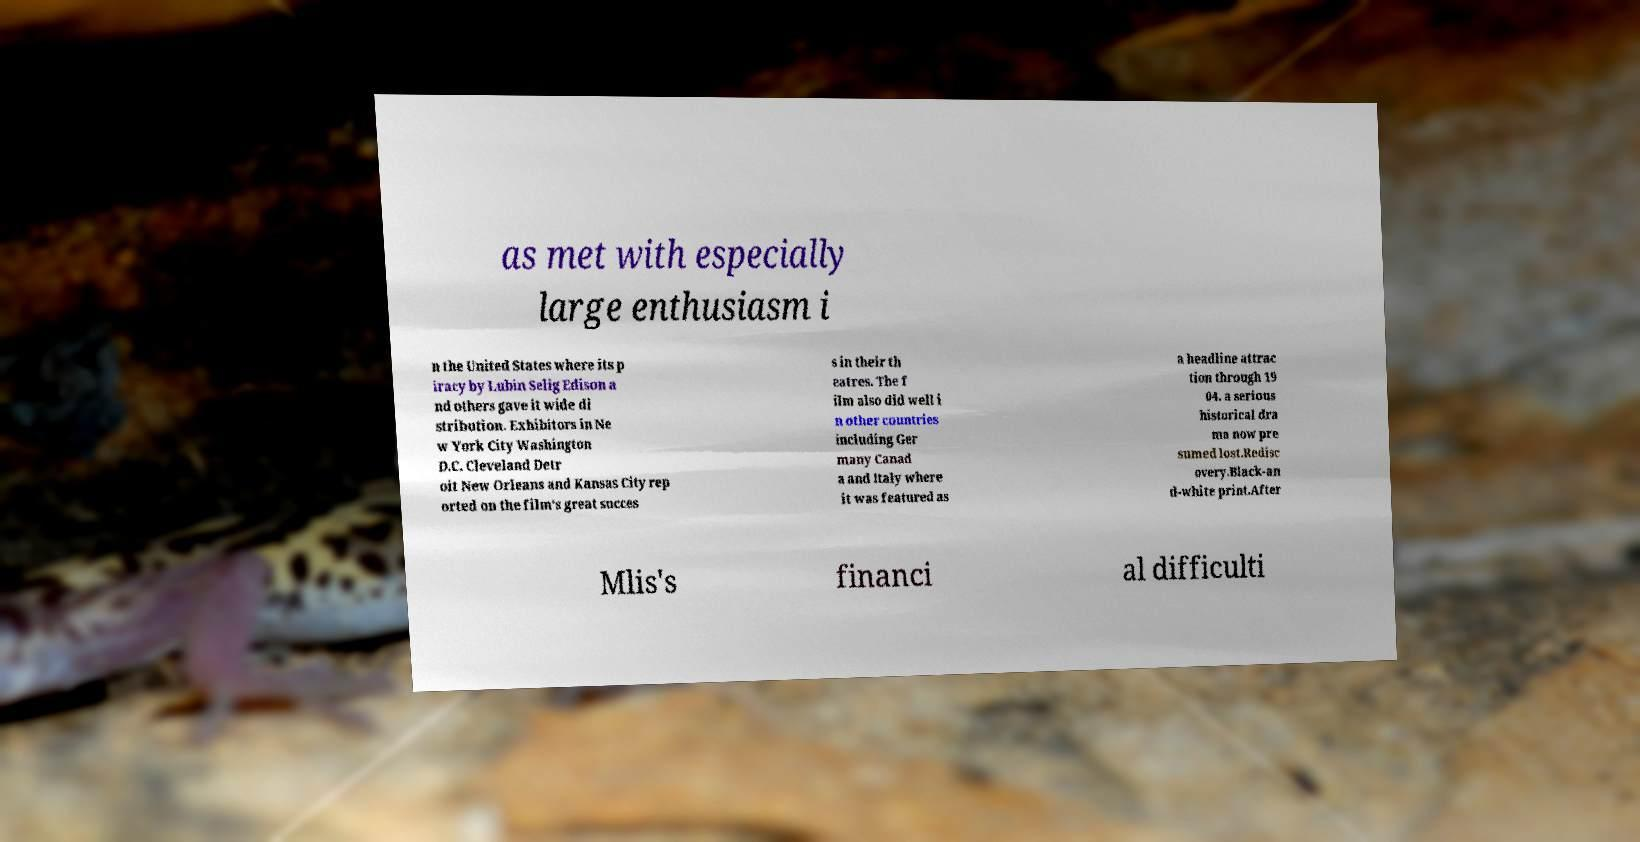There's text embedded in this image that I need extracted. Can you transcribe it verbatim? as met with especially large enthusiasm i n the United States where its p iracy by Lubin Selig Edison a nd others gave it wide di stribution. Exhibitors in Ne w York City Washington D.C. Cleveland Detr oit New Orleans and Kansas City rep orted on the film's great succes s in their th eatres. The f ilm also did well i n other countries including Ger many Canad a and Italy where it was featured as a headline attrac tion through 19 04. a serious historical dra ma now pre sumed lost.Redisc overy.Black-an d-white print.After Mlis's financi al difficulti 